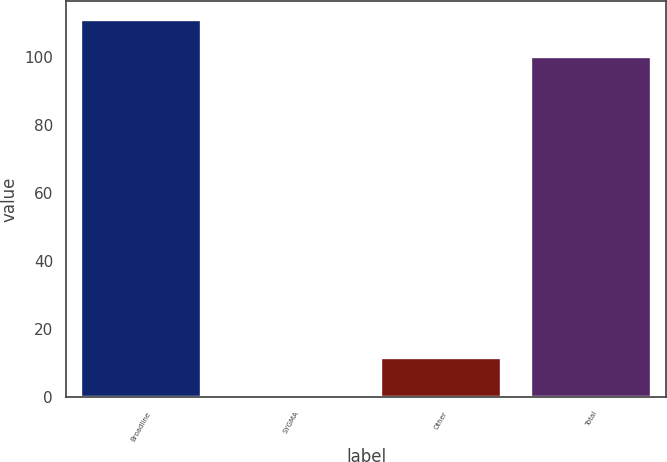<chart> <loc_0><loc_0><loc_500><loc_500><bar_chart><fcel>Broadline<fcel>SYGMA<fcel>Other<fcel>Total<nl><fcel>111.02<fcel>0.6<fcel>11.62<fcel>100<nl></chart> 